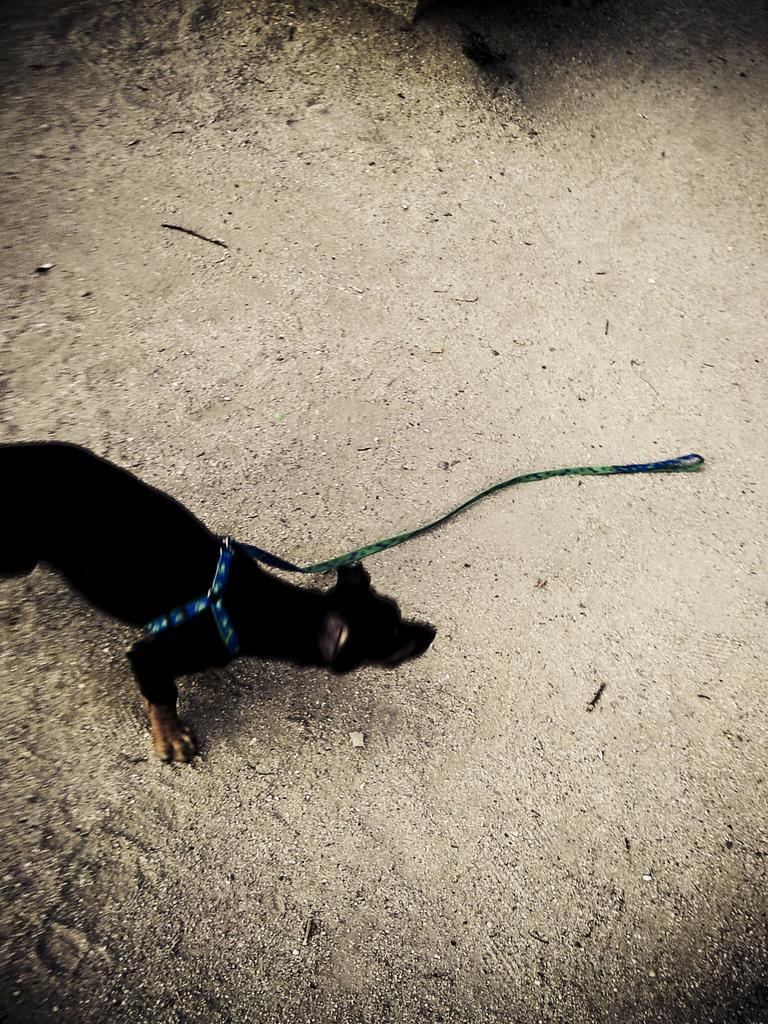What type of animal is in the image? There is a black color dog in the image. Is the dog wearing any accessories? Yes, the dog is wearing a belt. What can be seen in the background of the image? There is sand visible in the background of the image. What flavor of ice cream is being served on the stage in the image? There is no stage or ice cream present in the image; it features a black color dog wearing a belt with sand in the background. 